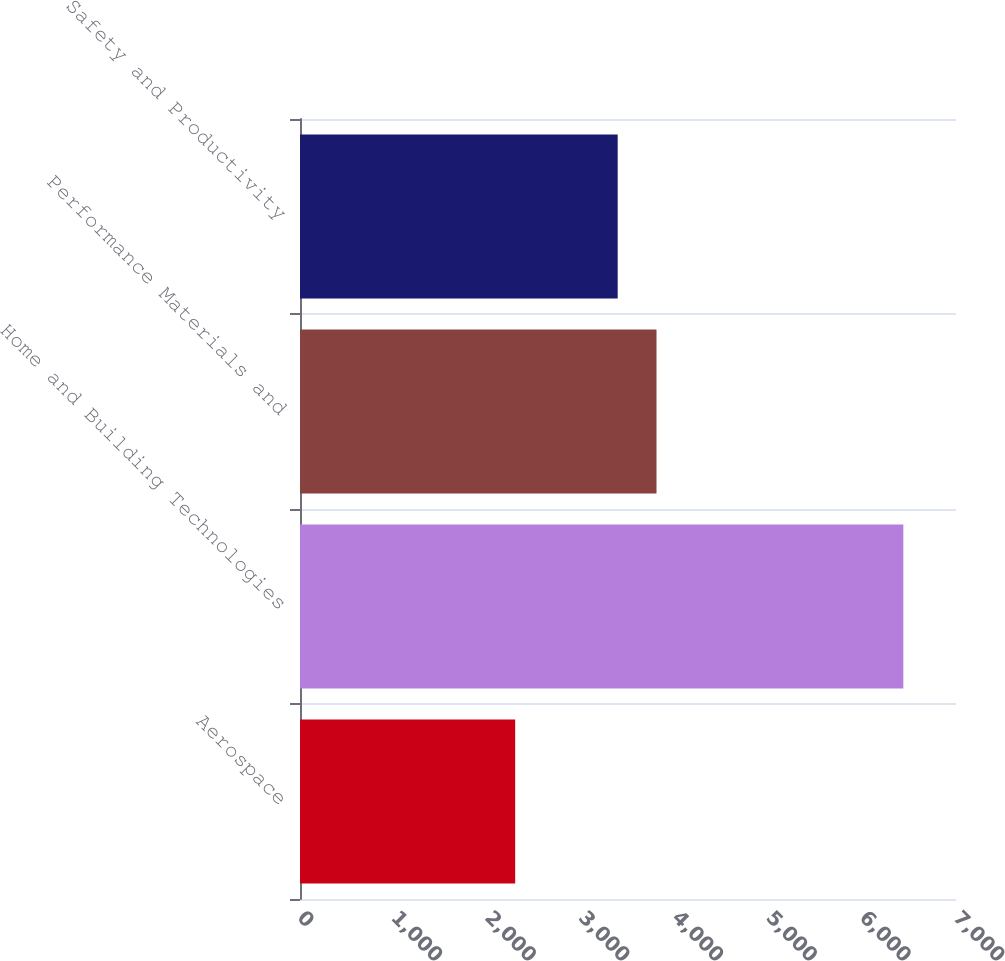Convert chart. <chart><loc_0><loc_0><loc_500><loc_500><bar_chart><fcel>Aerospace<fcel>Home and Building Technologies<fcel>Performance Materials and<fcel>Safety and Productivity<nl><fcel>2296<fcel>6438<fcel>3804.2<fcel>3390<nl></chart> 